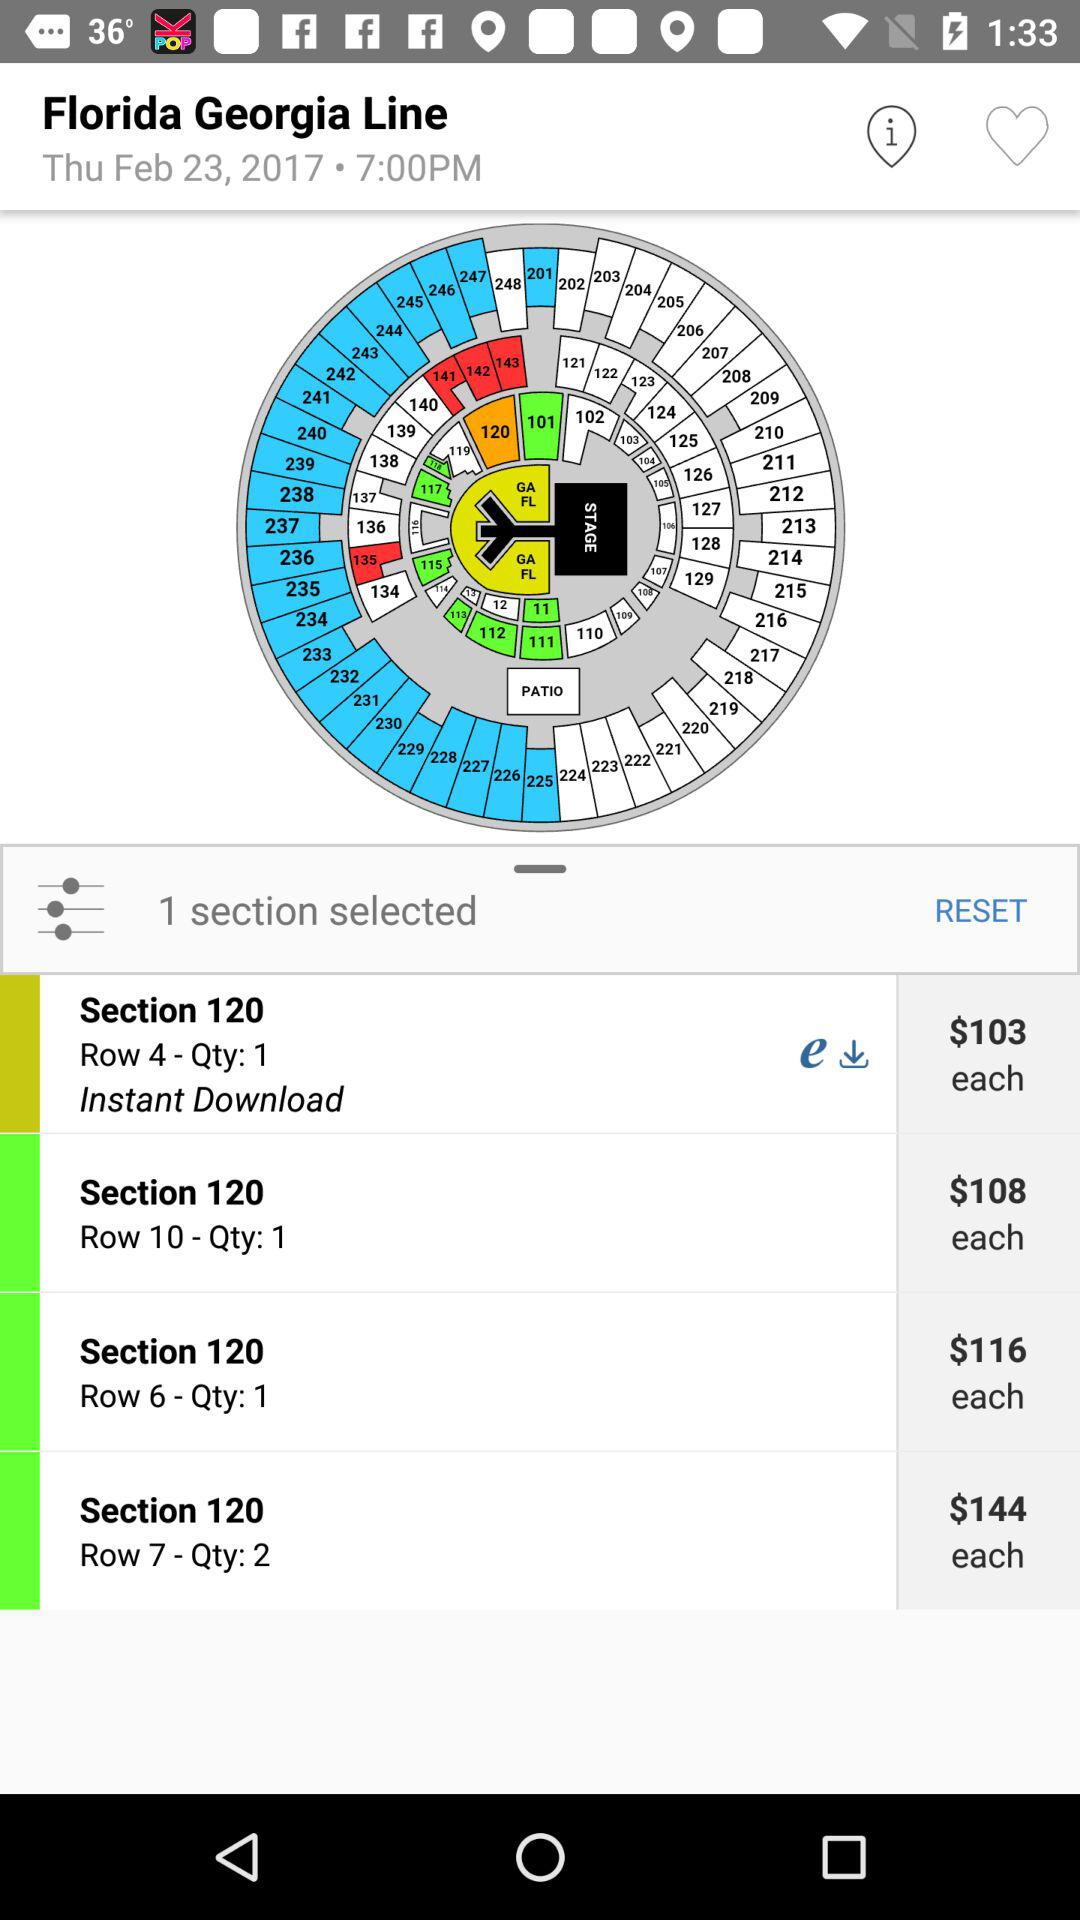How many sections have been selected? The number of sections that have been selected is 1. 